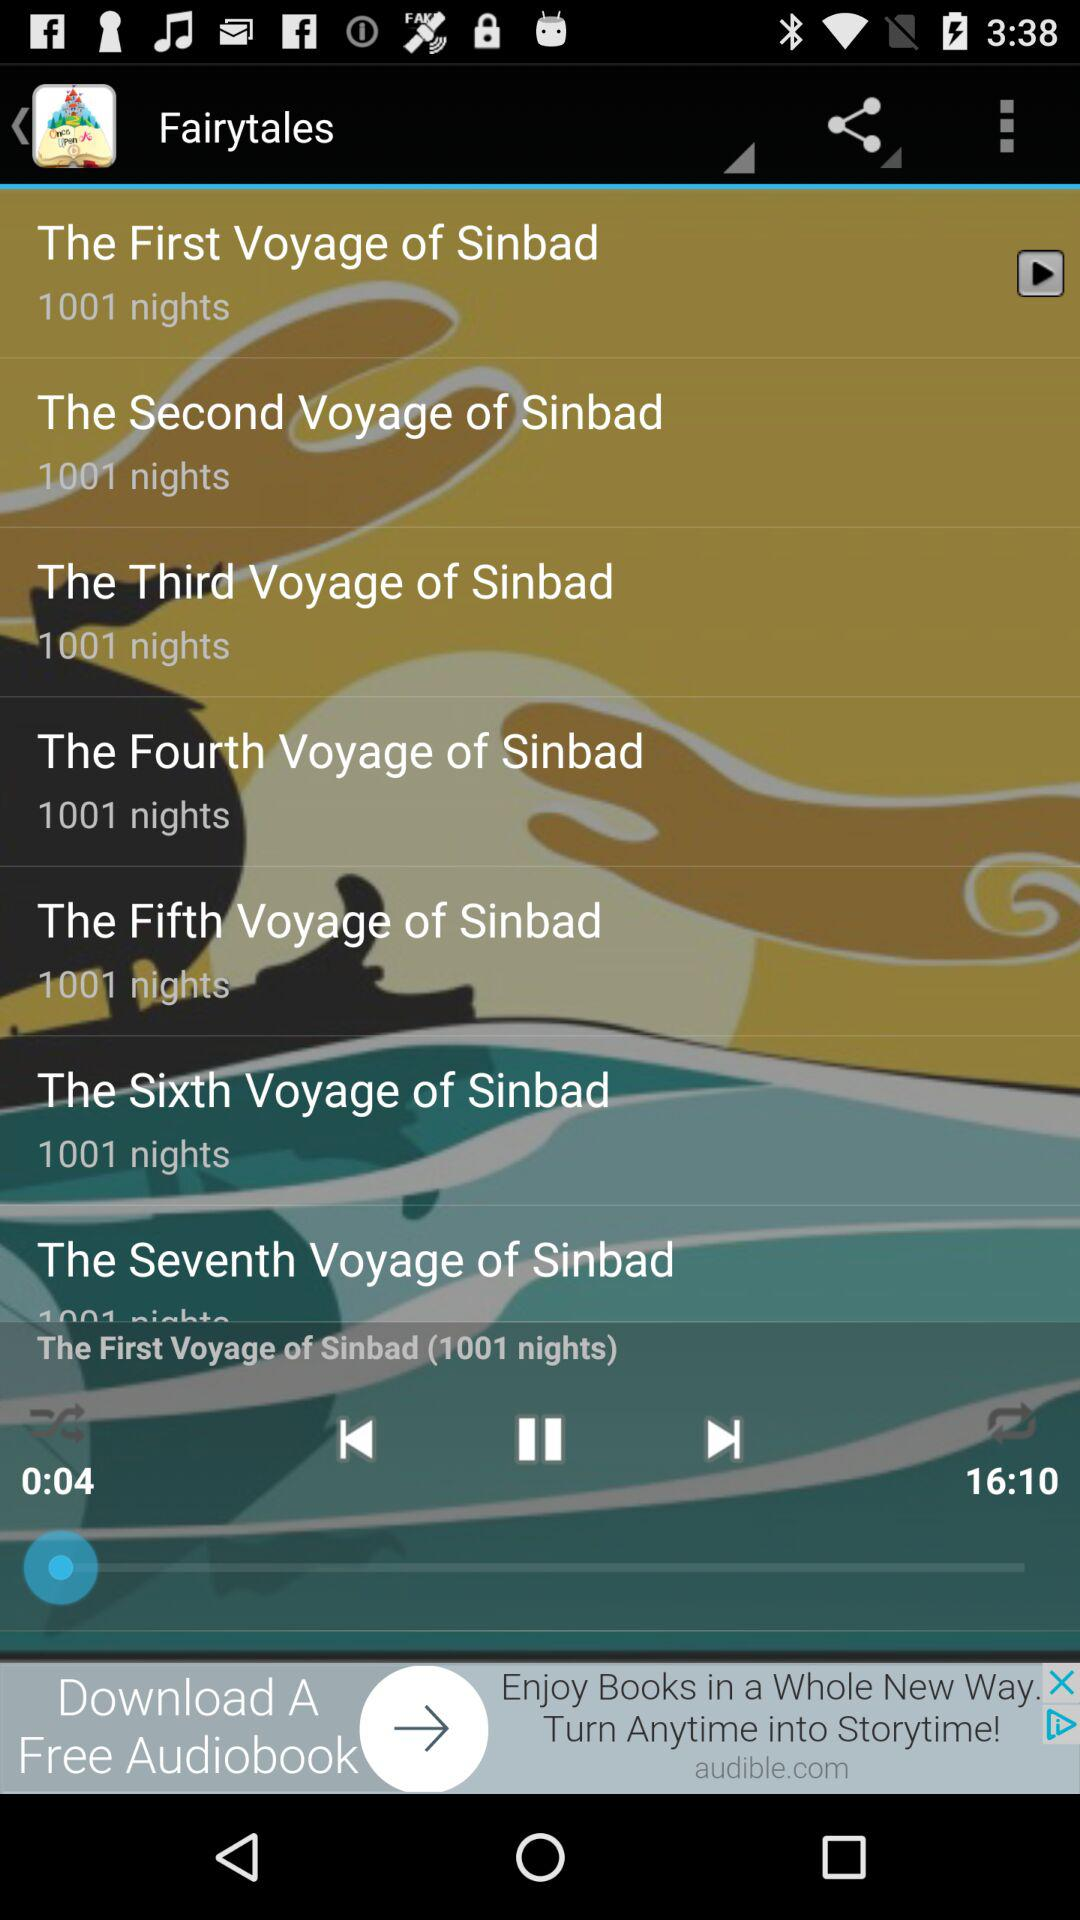How much audio has played? The audio has played for 0:04. 